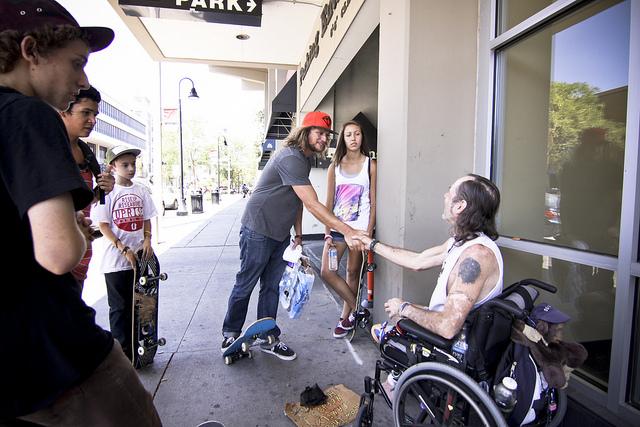What are the people riding?
Concise answer only. Skateboards. How many bikes in the shot?
Write a very short answer. 0. How many people are wearing hats in the photo?
Keep it brief. 3. What is the person doing?
Keep it brief. Shaking hands. What does the little boy think about this woman?
Answer briefly. Happy. What has two wheels?
Write a very short answer. Wheelchair. What the dog have on it's face?
Short answer required. No dog. Are they headed to a ski slope?
Write a very short answer. No. Does everyone here have a home?
Keep it brief. No. What city are the people in?
Quick response, please. Chicago. What is on the man's feet?
Keep it brief. Shoes. What kind of transportation is there?
Keep it brief. Wheelchair. What color is the tire?
Concise answer only. Gray. 